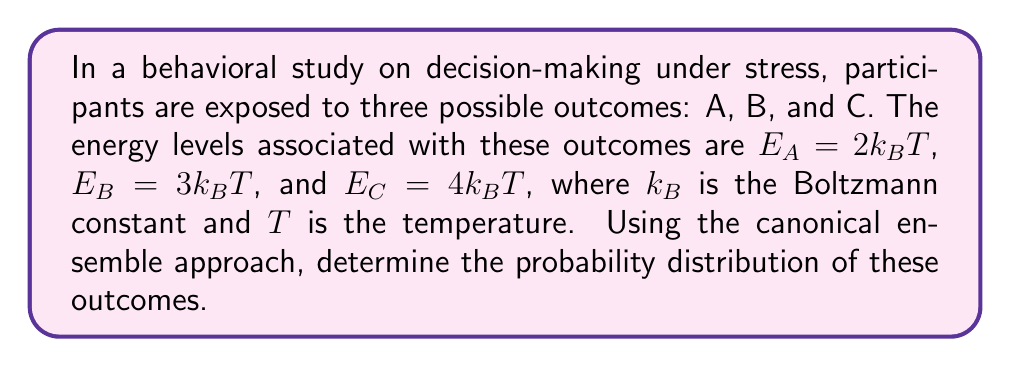Teach me how to tackle this problem. To solve this problem, we'll use the canonical ensemble approach from statistical mechanics. As a psychologist, you can think of this as a way to model how different mental states (outcomes) are distributed based on their associated "energy" levels.

Step 1: Recall the probability formula for the canonical ensemble
The probability of a particular state $i$ is given by:

$$P_i = \frac{e^{-E_i/k_BT}}{Z}$$

Where $Z$ is the partition function.

Step 2: Calculate the partition function
The partition function $Z$ is the sum of the Boltzmann factors for all states:

$$Z = \sum_i e^{-E_i/k_BT} = e^{-E_A/k_BT} + e^{-E_B/k_BT} + e^{-E_C/k_BT}$$

Substituting the given energy levels:

$$Z = e^{-2} + e^{-3} + e^{-4}$$

Step 3: Calculate the probabilities
For outcome A:
$$P_A = \frac{e^{-2}}{e^{-2} + e^{-3} + e^{-4}}$$

For outcome B:
$$P_B = \frac{e^{-3}}{e^{-2} + e^{-3} + e^{-4}}$$

For outcome C:
$$P_C = \frac{e^{-4}}{e^{-2} + e^{-3} + e^{-4}}$$

Step 4: Simplify and calculate numerical values
$$P_A = \frac{e^{-2}}{e^{-2} + e^{-3} + e^{-4}} \approx 0.6652$$
$$P_B = \frac{e^{-3}}{e^{-2} + e^{-3} + e^{-4}} \approx 0.2447$$
$$P_C = \frac{e^{-4}}{e^{-2} + e^{-3} + e^{-4}} \approx 0.0900$$

Note that $P_A + P_B + P_C = 1$, as expected for a probability distribution.
Answer: $P_A \approx 0.6652$, $P_B \approx 0.2447$, $P_C \approx 0.0900$ 